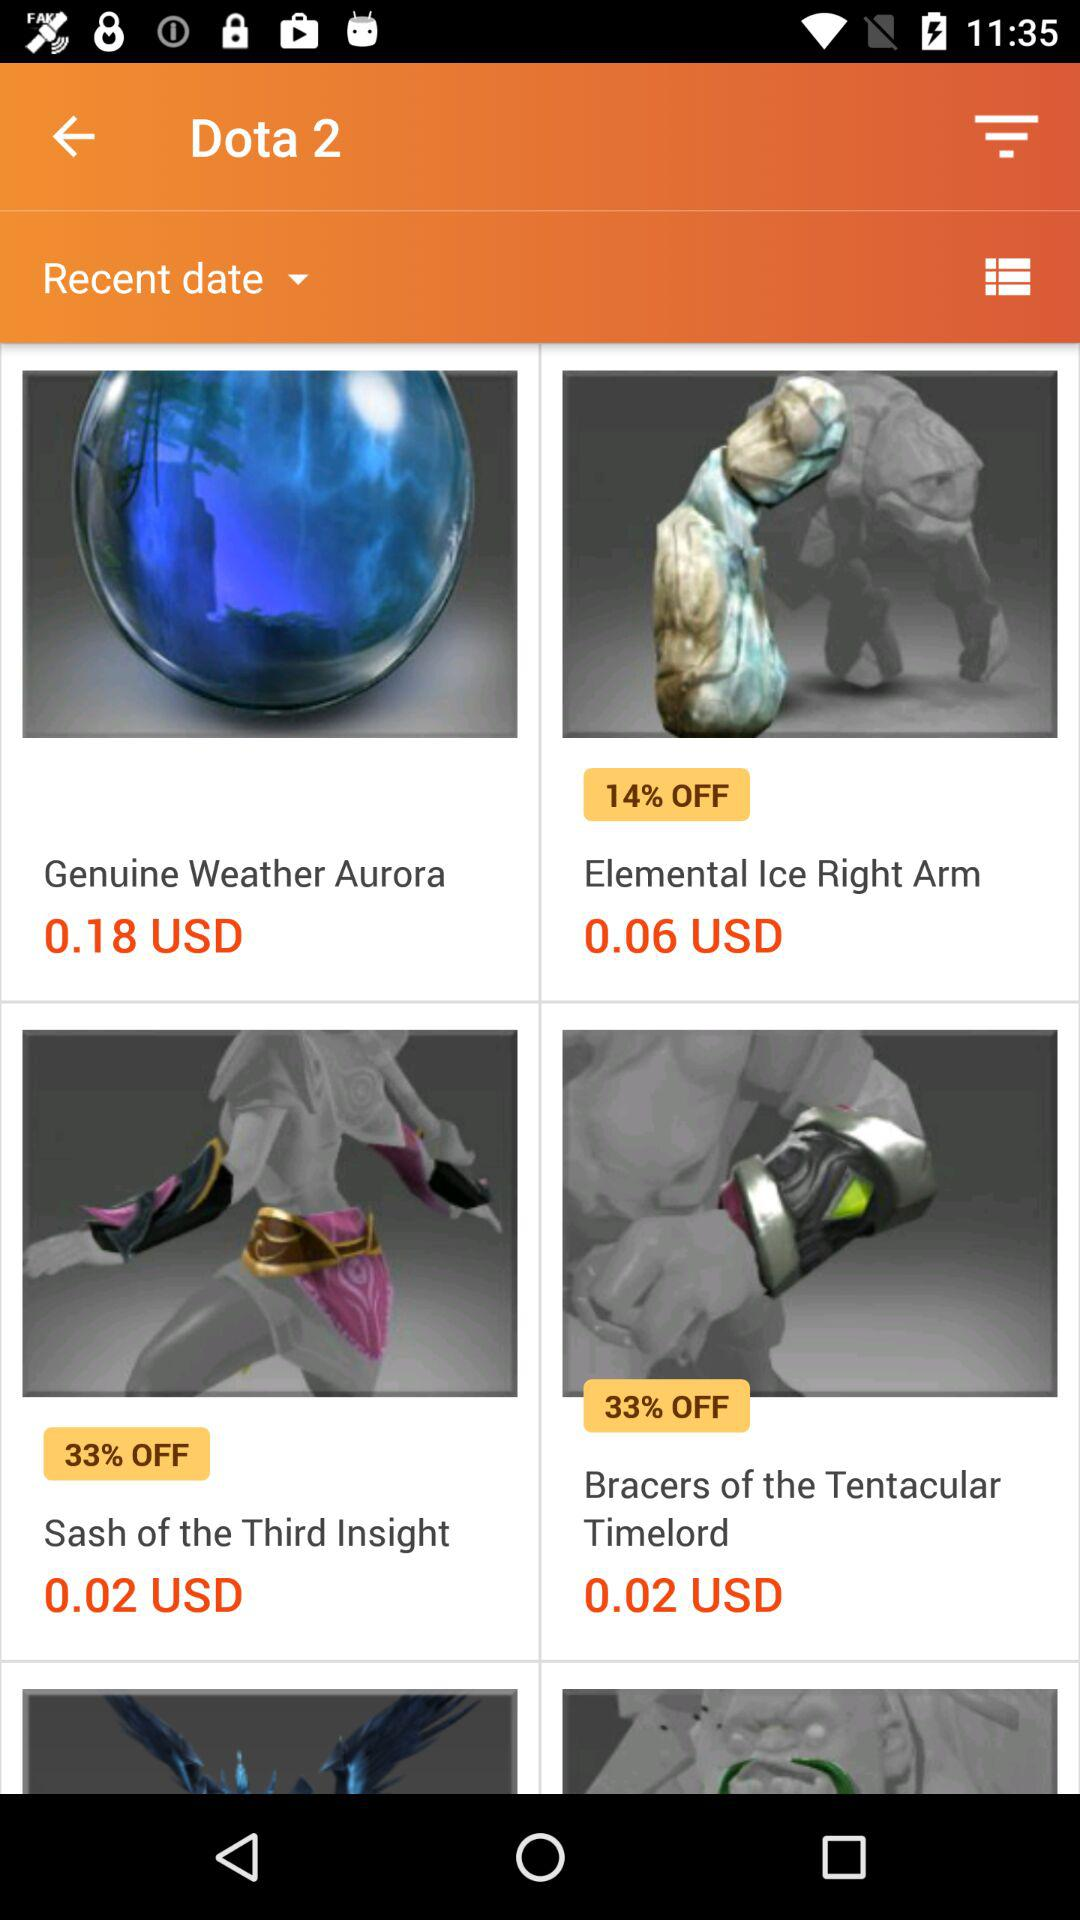How much is the price of the "Bracers of the Tentacular Timelord"? The price of the "Bracers of the Tentacular Timelord" is 0.02 USD. 